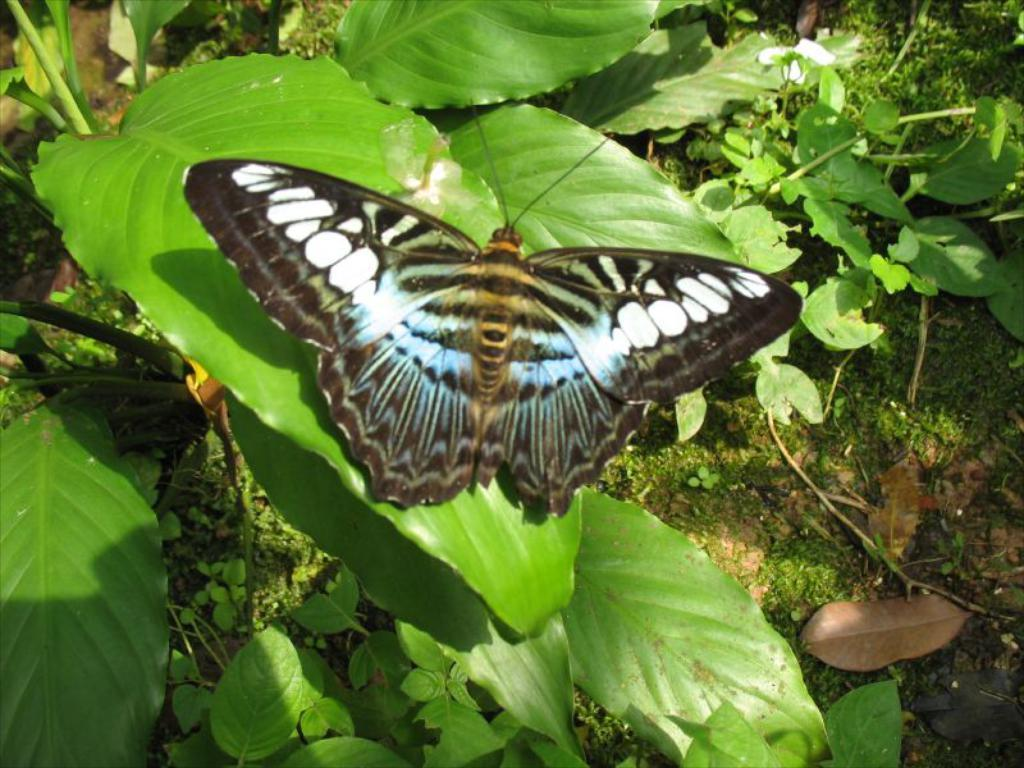What is the main subject of the image? The main subject of the image is a butterfly on a leaf. What type of plant is the butterfly resting on? The butterfly is on a leaf, which is part of a plant with stems and leaves. Can you describe the plants in the image? The plants in the image have stems and leaves. What type of cap is the butterfly wearing in the image? There is no cap present on the butterfly in the image. What is the profit margin for the plants in the image? The image does not provide any information about profit margins, as it is a photograph of a butterfly on a leaf and plants. 